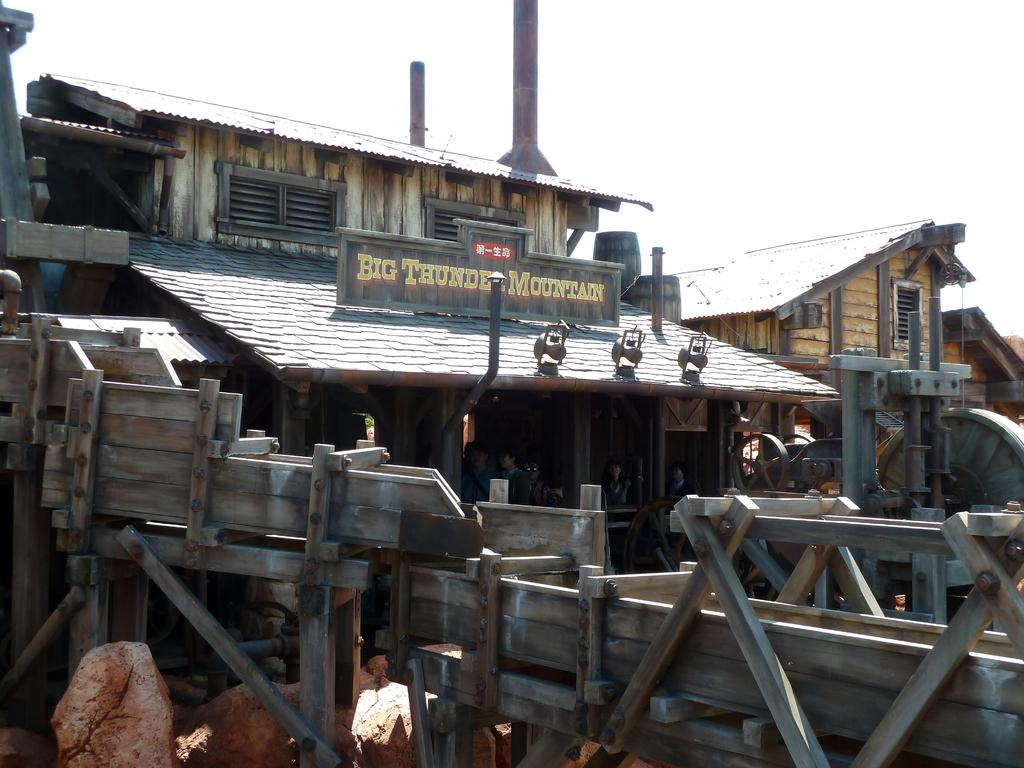What can be seen in the foreground of the image? There are stones and a wooden boundary in the foreground of the image. What is located in the center of the image? There are houses and a machine in the center of the image. What is visible in the background of the image? The sky is visible in the background of the image. Can you see a key being used to unlock the machine in the image? There is no key or any indication of unlocking in the image. Whose face can be seen in the image? There are no faces visible in the image. 